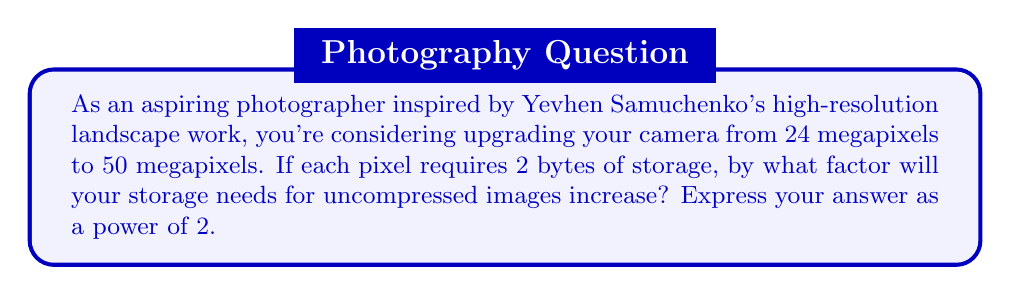Could you help me with this problem? Let's approach this step-by-step:

1) First, let's calculate the storage needed for a 24-megapixel image:
   $24 \times 10^6$ pixels $\times 2$ bytes/pixel = $48 \times 10^6$ bytes

2) Now, let's calculate the storage needed for a 50-megapixel image:
   $50 \times 10^6$ pixels $\times 2$ bytes/pixel = $100 \times 10^6$ bytes

3) To find the factor of increase, we divide the new storage requirement by the old:
   $$\frac{100 \times 10^6}{48 \times 10^6} = \frac{25}{12} \approx 2.0833$$

4) We need to express this as a power of 2. Let's call this power $x$:
   $$2^x = \frac{25}{12}$$

5) Taking the logarithm (base 2) of both sides:
   $$x = \log_2(\frac{25}{12}) \approx 1.0591$$

6) Rounding to the nearest power of 2, we get $2^1 = 2$

Therefore, the storage needs will approximately double, which can be expressed as $2^1$.
Answer: $2^1$ 